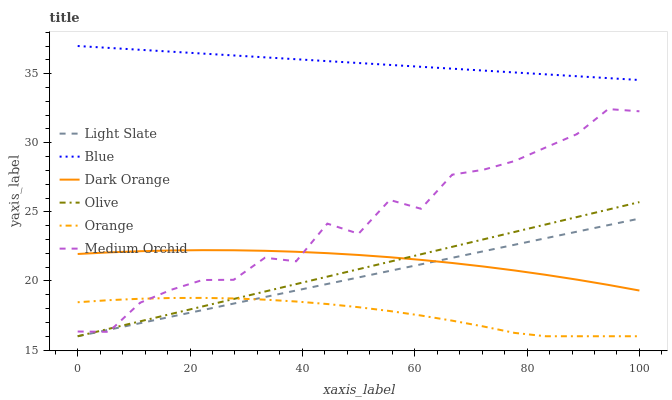Does Orange have the minimum area under the curve?
Answer yes or no. Yes. Does Blue have the maximum area under the curve?
Answer yes or no. Yes. Does Dark Orange have the minimum area under the curve?
Answer yes or no. No. Does Dark Orange have the maximum area under the curve?
Answer yes or no. No. Is Light Slate the smoothest?
Answer yes or no. Yes. Is Medium Orchid the roughest?
Answer yes or no. Yes. Is Dark Orange the smoothest?
Answer yes or no. No. Is Dark Orange the roughest?
Answer yes or no. No. Does Light Slate have the lowest value?
Answer yes or no. Yes. Does Dark Orange have the lowest value?
Answer yes or no. No. Does Blue have the highest value?
Answer yes or no. Yes. Does Dark Orange have the highest value?
Answer yes or no. No. Is Dark Orange less than Blue?
Answer yes or no. Yes. Is Blue greater than Medium Orchid?
Answer yes or no. Yes. Does Medium Orchid intersect Orange?
Answer yes or no. Yes. Is Medium Orchid less than Orange?
Answer yes or no. No. Is Medium Orchid greater than Orange?
Answer yes or no. No. Does Dark Orange intersect Blue?
Answer yes or no. No. 